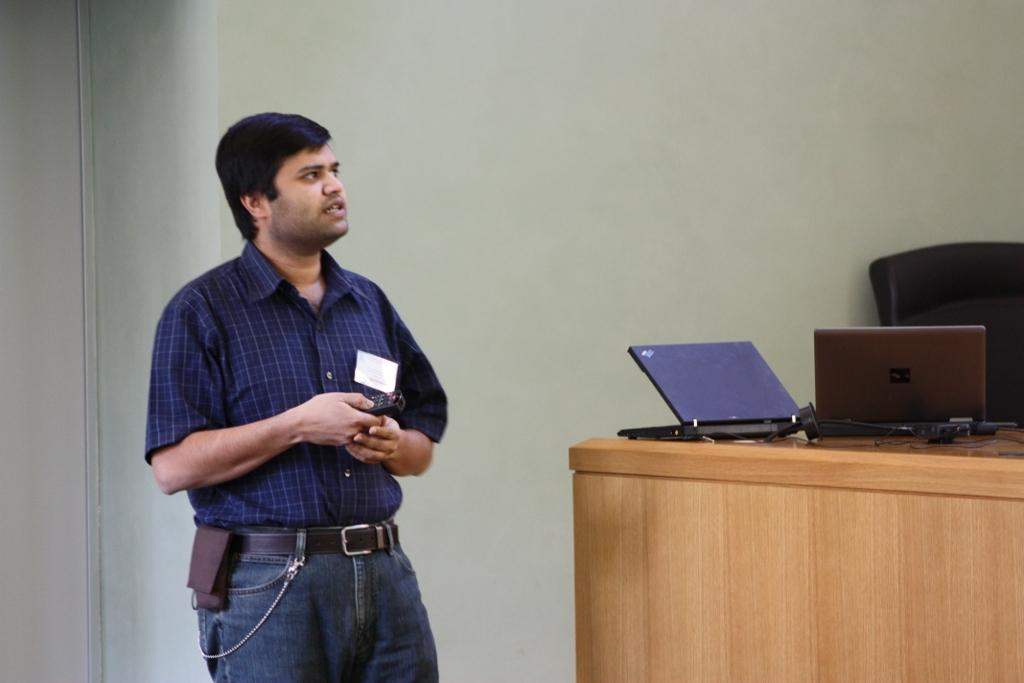Who is present in the image? There is a man in the image. What is the man doing in the image? The man is standing in front of a table. What objects are on the table in the image? There are laptops on the table. What type of cream can be seen in the man's hand in the image? There is no cream present in the image, and the man's hands are not visible. 